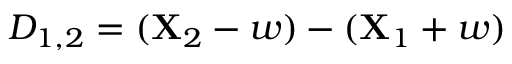<formula> <loc_0><loc_0><loc_500><loc_500>D _ { 1 , 2 } = ( X _ { 2 } - w ) - ( X _ { 1 } + w )</formula> 